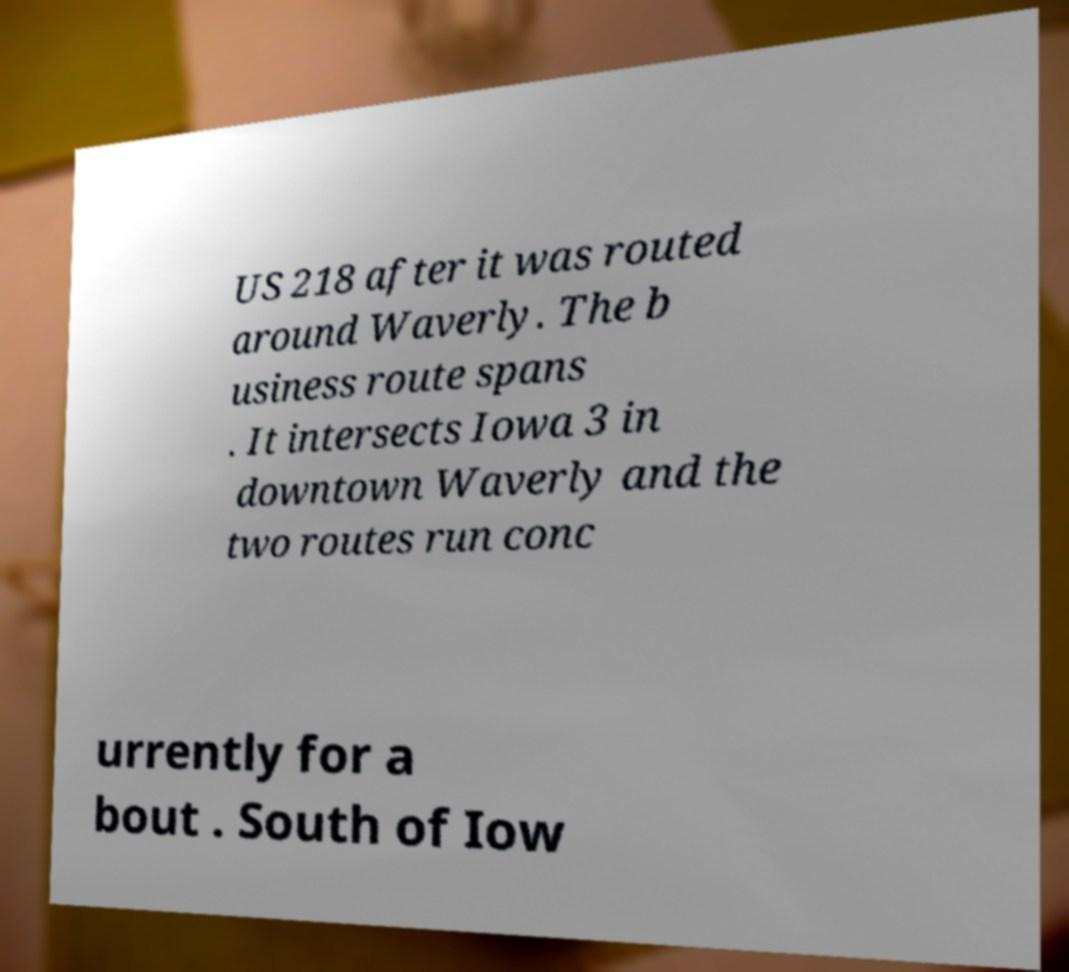Could you extract and type out the text from this image? US 218 after it was routed around Waverly. The b usiness route spans . It intersects Iowa 3 in downtown Waverly and the two routes run conc urrently for a bout . South of Iow 